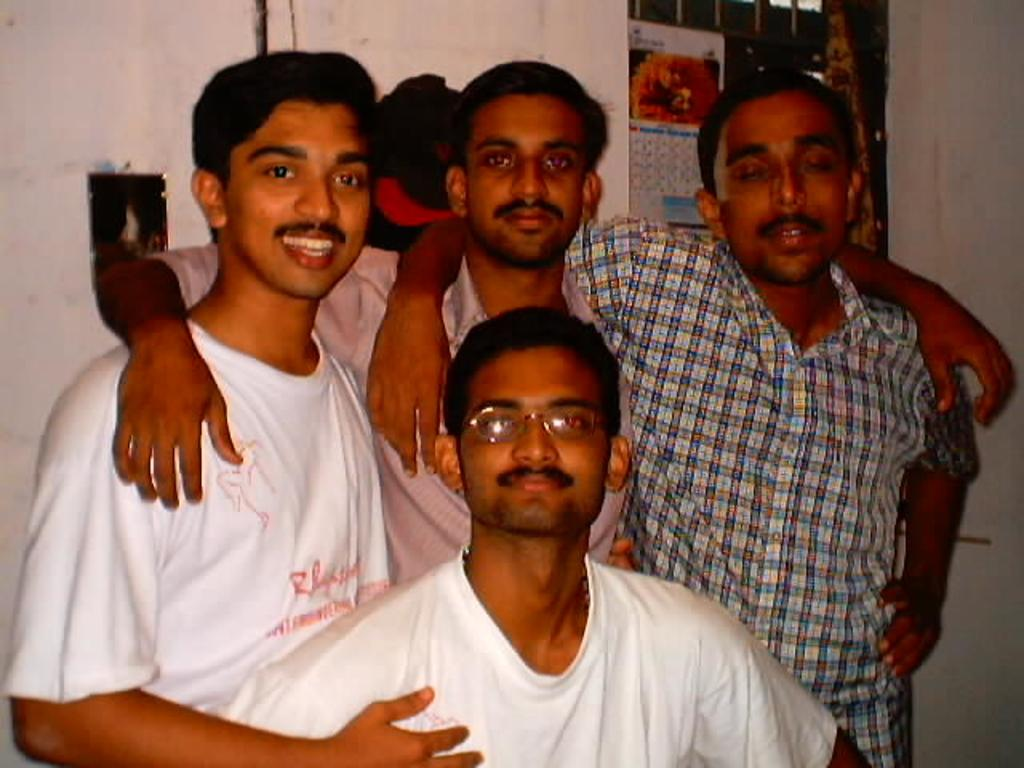Where was the image taken? The image was taken indoors. What can be seen in the background of the image? There is a wall with a window in the background. What is hanging on the wall in the image? There is a calendar on the wall. How many men are present in the image? Four men are standing in the middle of the image. What type of instrument is being played by the men in the image? There is no instrument present in the image; the men are not playing any music. Can you see any fish swimming in the background of the image? There are no fish visible in the image, as it was taken indoors and does not feature any aquatic elements. 